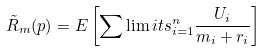<formula> <loc_0><loc_0><loc_500><loc_500>\tilde { R } _ { m } ( p ) = E \left [ \sum \lim i t s _ { i = 1 } ^ { n } \frac { U _ { i } } { m _ { i } + r _ { i } } \right ]</formula> 